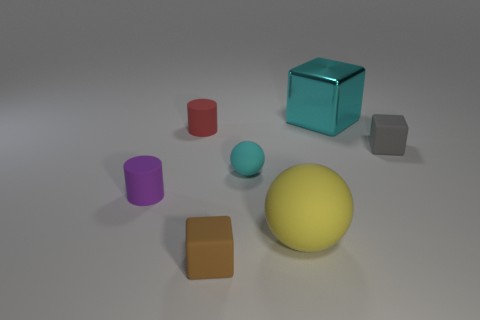Subtract all small brown blocks. How many blocks are left? 2 Add 2 rubber cylinders. How many objects exist? 9 Subtract 2 cubes. How many cubes are left? 1 Subtract all cylinders. How many objects are left? 5 Subtract all blue cylinders. Subtract all red balls. How many cylinders are left? 2 Subtract all blue cubes. How many cyan cylinders are left? 0 Subtract all balls. Subtract all spheres. How many objects are left? 3 Add 6 gray things. How many gray things are left? 7 Add 6 red metallic things. How many red metallic things exist? 6 Subtract all red cylinders. How many cylinders are left? 1 